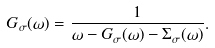Convert formula to latex. <formula><loc_0><loc_0><loc_500><loc_500>G _ { \sigma } ( \omega ) = \frac { 1 } { \omega - G _ { \sigma } ( \omega ) - \Sigma _ { \sigma } ( \omega ) } .</formula> 